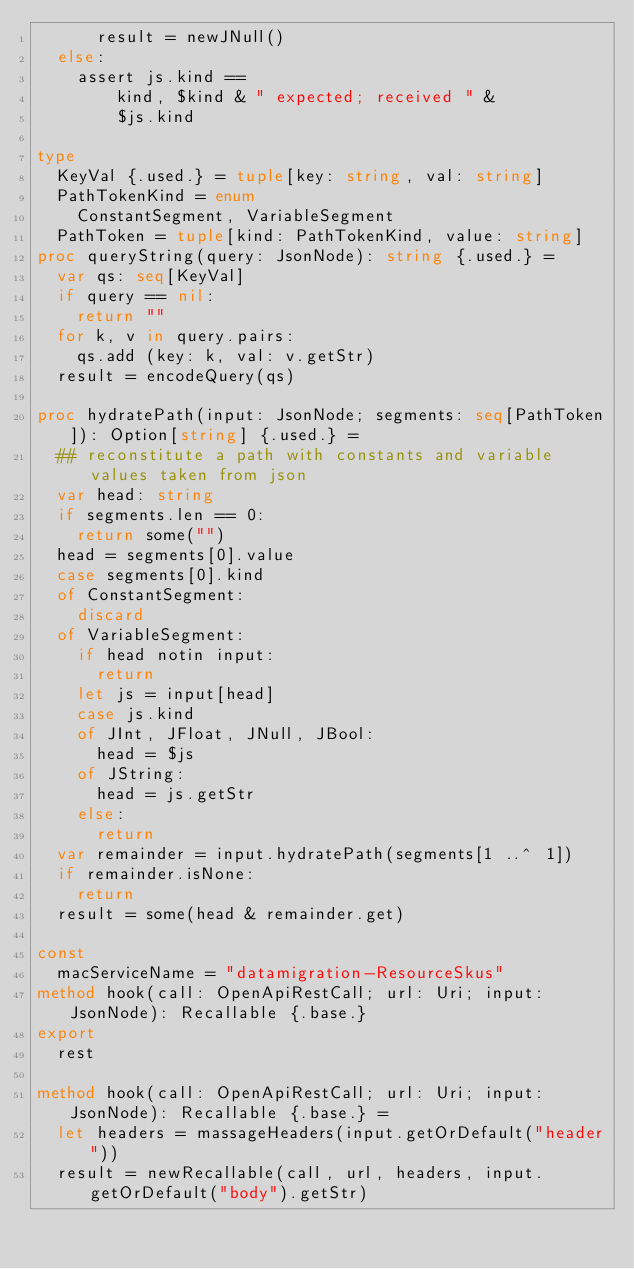Convert code to text. <code><loc_0><loc_0><loc_500><loc_500><_Nim_>      result = newJNull()
  else:
    assert js.kind ==
        kind, $kind & " expected; received " &
        $js.kind

type
  KeyVal {.used.} = tuple[key: string, val: string]
  PathTokenKind = enum
    ConstantSegment, VariableSegment
  PathToken = tuple[kind: PathTokenKind, value: string]
proc queryString(query: JsonNode): string {.used.} =
  var qs: seq[KeyVal]
  if query == nil:
    return ""
  for k, v in query.pairs:
    qs.add (key: k, val: v.getStr)
  result = encodeQuery(qs)

proc hydratePath(input: JsonNode; segments: seq[PathToken]): Option[string] {.used.} =
  ## reconstitute a path with constants and variable values taken from json
  var head: string
  if segments.len == 0:
    return some("")
  head = segments[0].value
  case segments[0].kind
  of ConstantSegment:
    discard
  of VariableSegment:
    if head notin input:
      return
    let js = input[head]
    case js.kind
    of JInt, JFloat, JNull, JBool:
      head = $js
    of JString:
      head = js.getStr
    else:
      return
  var remainder = input.hydratePath(segments[1 ..^ 1])
  if remainder.isNone:
    return
  result = some(head & remainder.get)

const
  macServiceName = "datamigration-ResourceSkus"
method hook(call: OpenApiRestCall; url: Uri; input: JsonNode): Recallable {.base.}
export
  rest

method hook(call: OpenApiRestCall; url: Uri; input: JsonNode): Recallable {.base.} =
  let headers = massageHeaders(input.getOrDefault("header"))
  result = newRecallable(call, url, headers, input.getOrDefault("body").getStr)
</code> 